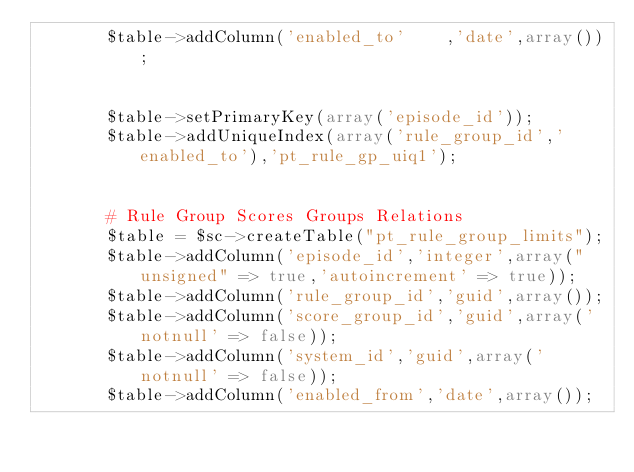<code> <loc_0><loc_0><loc_500><loc_500><_PHP_>       $table->addColumn('enabled_to'    ,'date',array());
       
       
       $table->setPrimaryKey(array('episode_id'));
       $table->addUniqueIndex(array('rule_group_id','enabled_to'),'pt_rule_gp_uiq1');
       
       
       # Rule Group Scores Groups Relations
       $table = $sc->createTable("pt_rule_group_limits");
       $table->addColumn('episode_id','integer',array("unsigned" => true,'autoincrement' => true));
       $table->addColumn('rule_group_id','guid',array());
       $table->addColumn('score_group_id','guid',array('notnull' => false)); 
       $table->addColumn('system_id','guid',array('notnull' => false)); 
       $table->addColumn('enabled_from','date',array());</code> 